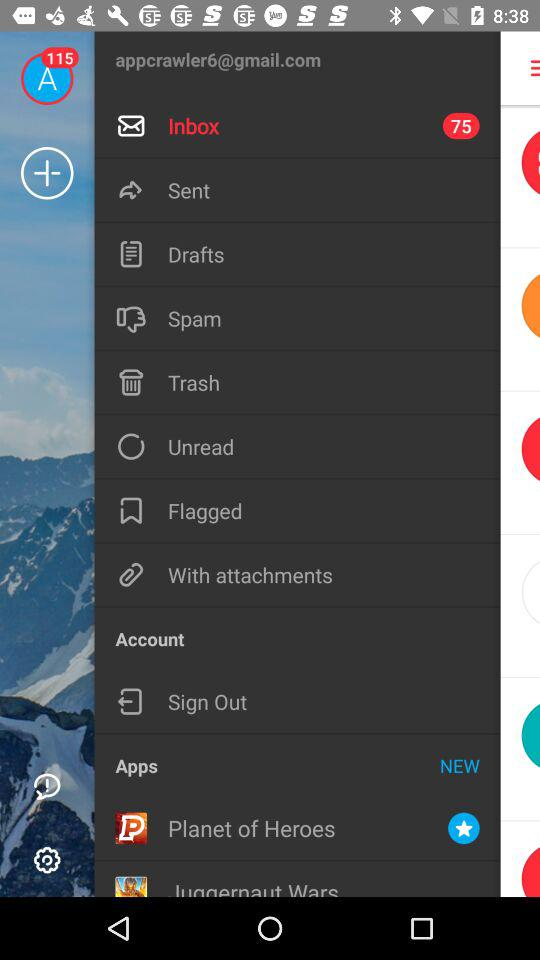How many unread emails do I have?
Answer the question using a single word or phrase. 75 